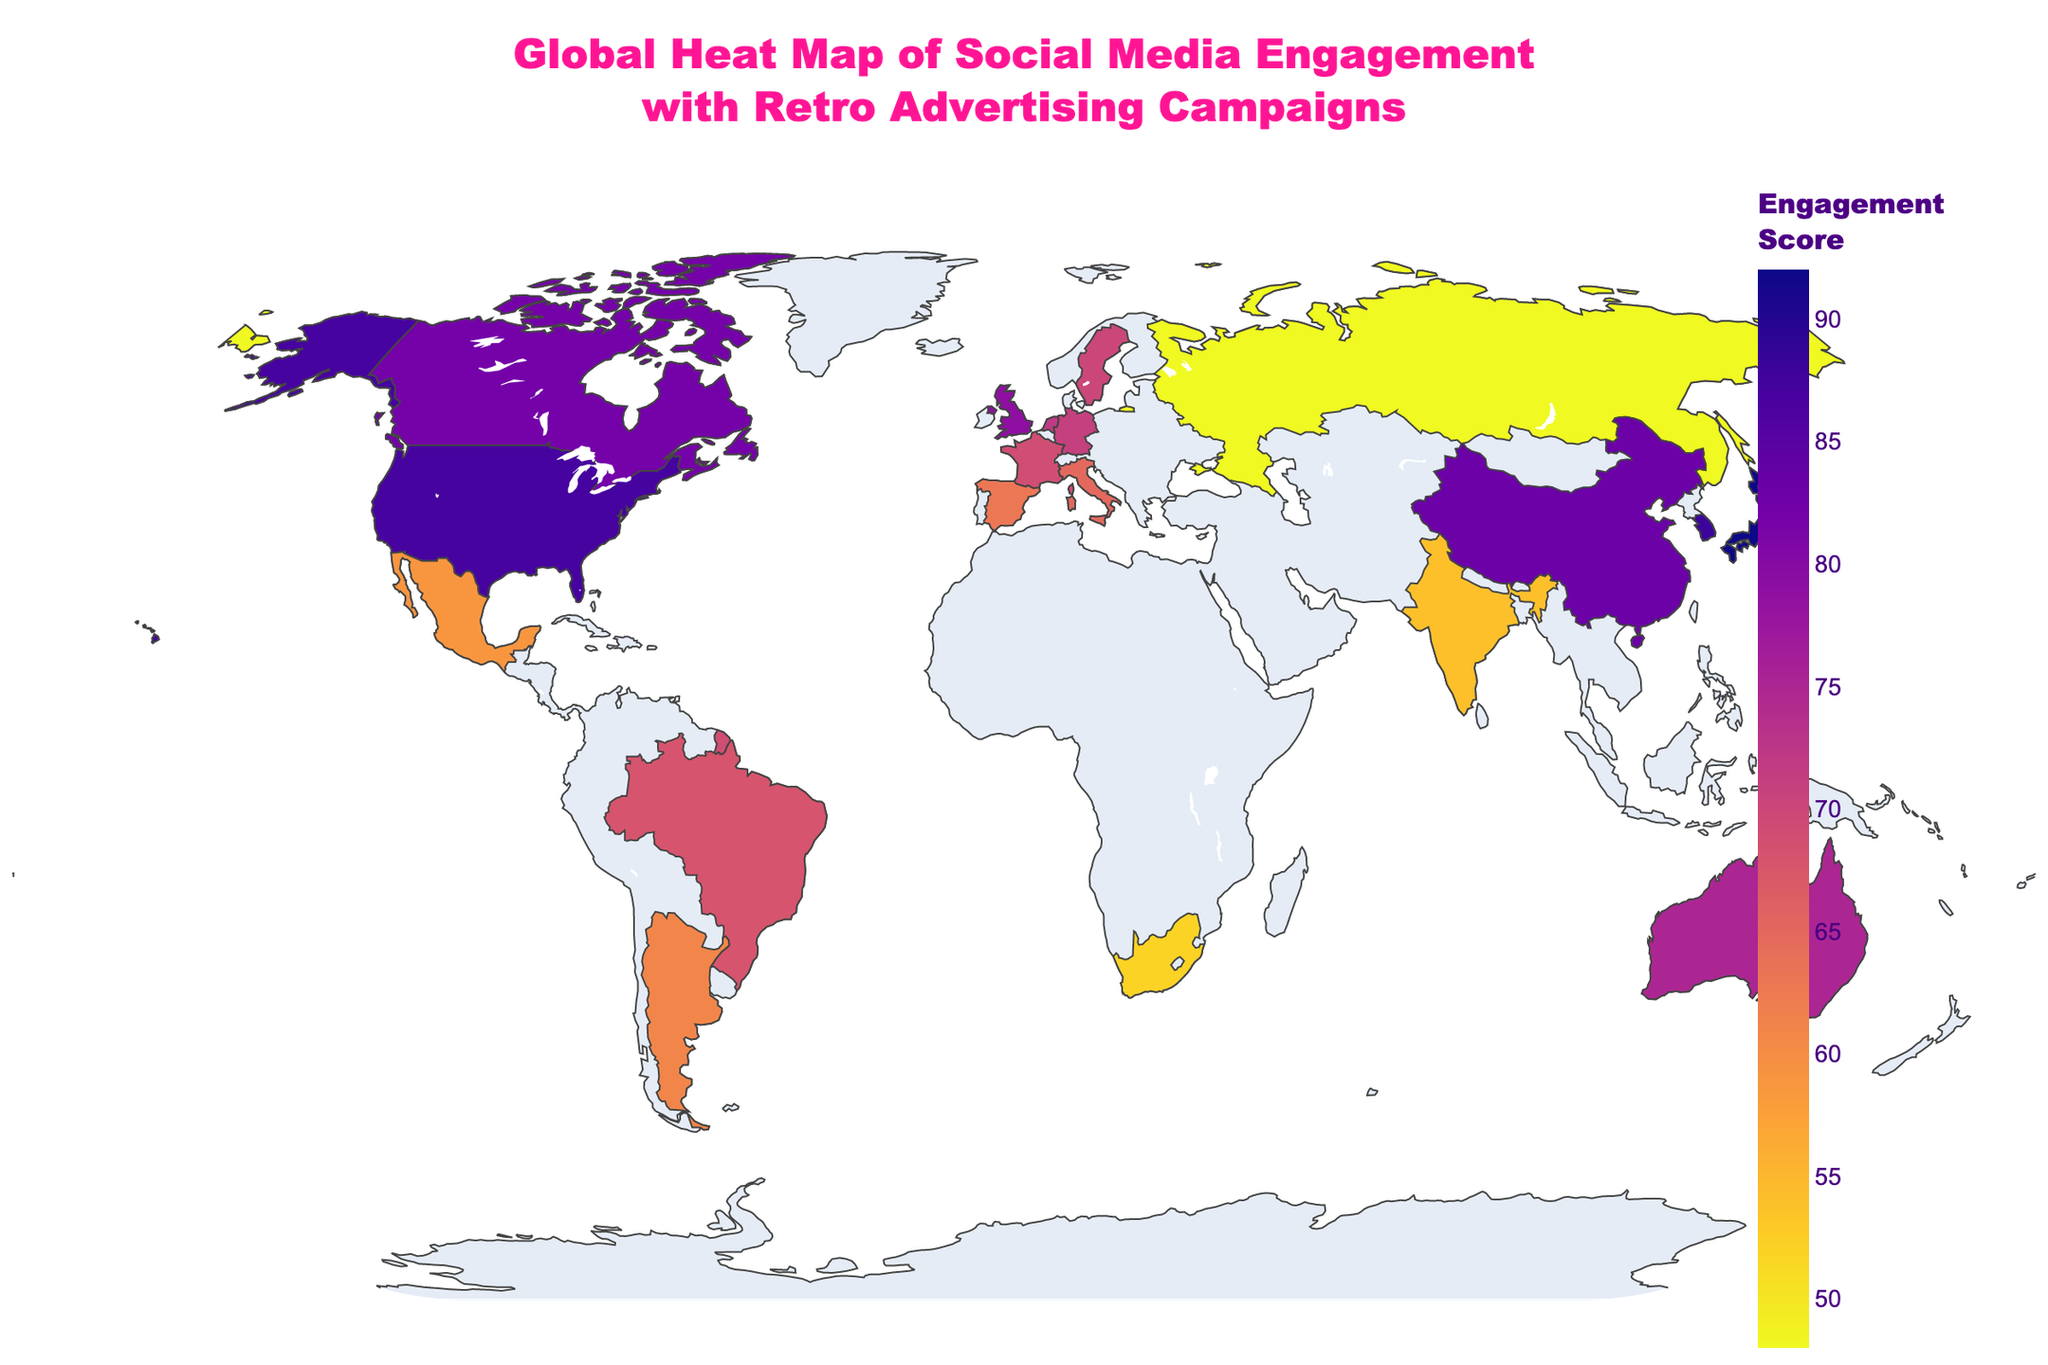What's the title of the figure? The title of the figure is displayed prominently at the top of the map. It is written in a large, bold font for clear visibility.
Answer: Global Heat Map of Social Media Engagement with Retro Advertising Campaigns Which country in East Asia has the highest engagement score? In East Asia, the highest engagement score can be identified by the darkest color intensity. By examining the map, Japan has the highest engagement score of 92.
Answer: Japan What is the engagement score of Brazil? To find Brazil's engagement score, locate the country on the map in South America and check the color gradient and hover information. It shows an engagement score of 68.
Answer: 68 Which country has the lowest engagement score and what is it? By identifying the country with the lightest shading on the map, Russia has the lowest engagement score of 48.
Answer: Russia What's the total engagement score for North American countries? North America includes the United States (87), Canada (82), and Mexico (59). Summing these up: 87 + 82 + 59 = 228.
Answer: 228 How does Singapore's engagement compare to Australia's? By comparing the colors on the map for Singapore and Australia, and checking the exact scores, Singapore (76) has a slightly higher engagement score than Australia (75).
Answer: Singapore has higher engagement What is the median engagement score for European countries? The engagement scores for European countries are 79 (UK), 71 (Germany), 69 (France), 65 (Italy), 63 (Spain), 72 (Netherlands), 70 (Sweden), and 48 (Russia). Ordering these values: 48, 63, 65, 69, 70, 71, 72, 79. The median is the average of the two middle values (69 and 70), so (69 + 70) / 2 = 69.5.
Answer: 69.5 Which region shows the highest average engagement score? Calculate the average scores for each region and compare. Here are the averages: North America (76), East Asia (87.67), Europe (64.78), South America (64.5), Oceania (75), Southeast Asia (76), South Asia (54), and Africa (52). East Asia has the highest average engagement score.
Answer: East Asia Is there a country in the data from Africa? If so, what is its engagement score? Yes, by examining the map and dataset, South Africa is the only African country listed, and its engagement score is 52.
Answer: Yes, 52 